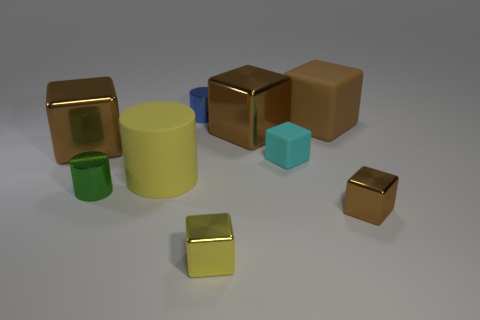Subtract all brown blocks. How many were subtracted if there are2brown blocks left? 2 Subtract all cyan matte blocks. How many blocks are left? 5 Subtract all brown cylinders. How many brown blocks are left? 4 Subtract all cyan cubes. How many cubes are left? 5 Subtract 1 brown cubes. How many objects are left? 8 Subtract all cubes. How many objects are left? 3 Subtract 4 cubes. How many cubes are left? 2 Subtract all brown blocks. Subtract all gray balls. How many blocks are left? 2 Subtract all blue objects. Subtract all cylinders. How many objects are left? 5 Add 9 tiny rubber blocks. How many tiny rubber blocks are left? 10 